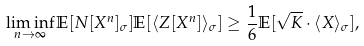<formula> <loc_0><loc_0><loc_500><loc_500>\liminf _ { n \to \infty } \mathbb { E } [ N [ X ^ { n } ] _ { \sigma } ] \mathbb { E } [ \langle Z [ X ^ { n } ] \rangle _ { \sigma } ] \geq \frac { 1 } { 6 } \mathbb { E } [ \sqrt { K } \cdot \langle X \rangle _ { \sigma } ] ,</formula> 